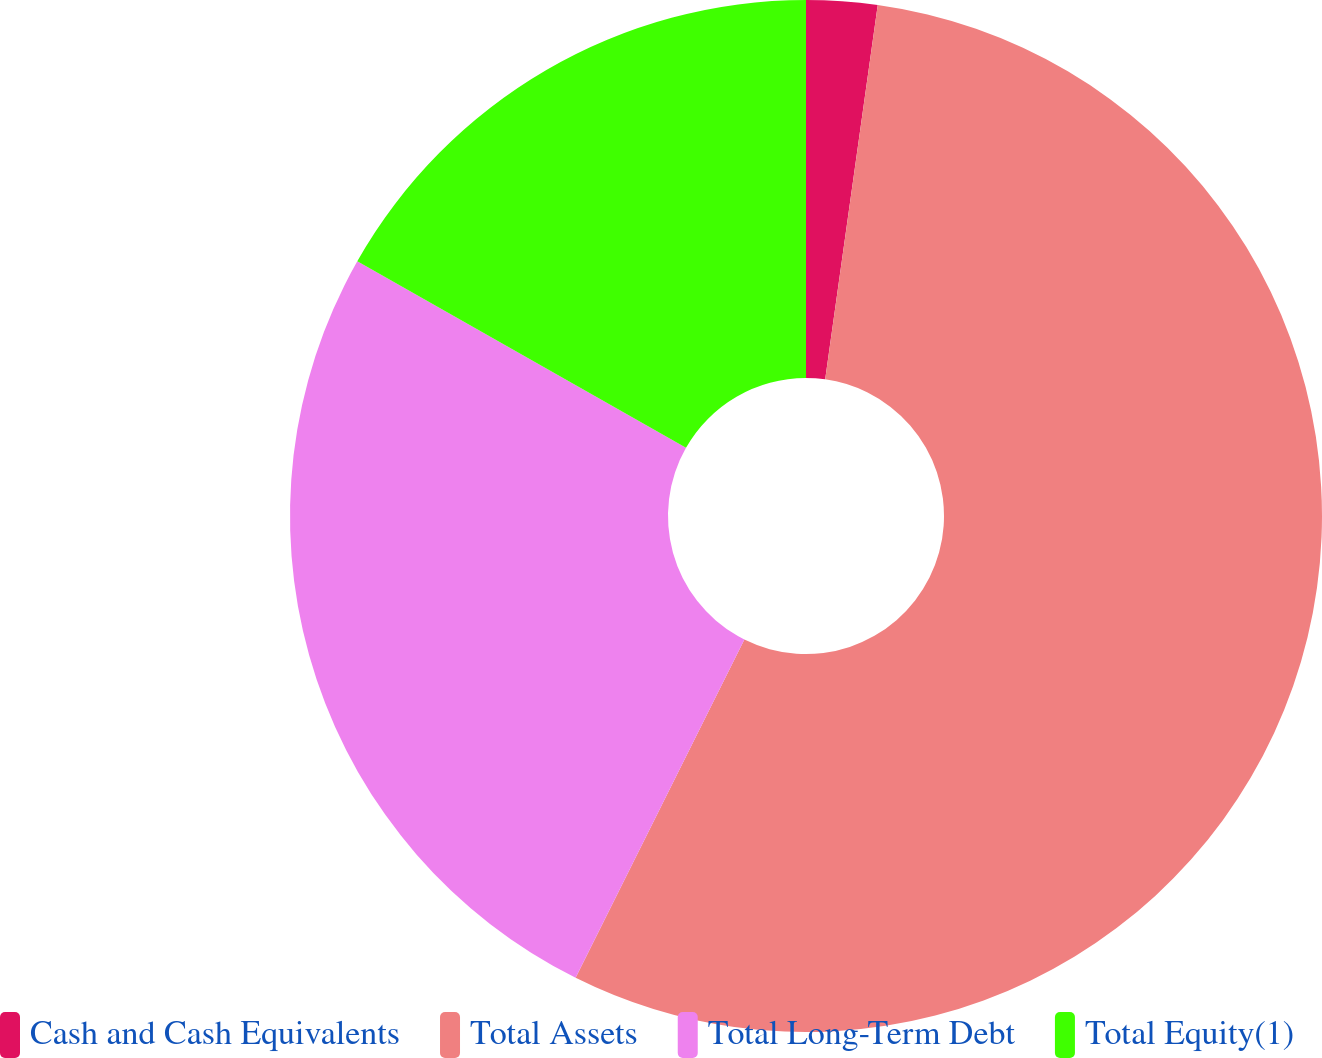Convert chart to OTSL. <chart><loc_0><loc_0><loc_500><loc_500><pie_chart><fcel>Cash and Cash Equivalents<fcel>Total Assets<fcel>Total Long-Term Debt<fcel>Total Equity(1)<nl><fcel>2.22%<fcel>55.14%<fcel>25.85%<fcel>16.78%<nl></chart> 